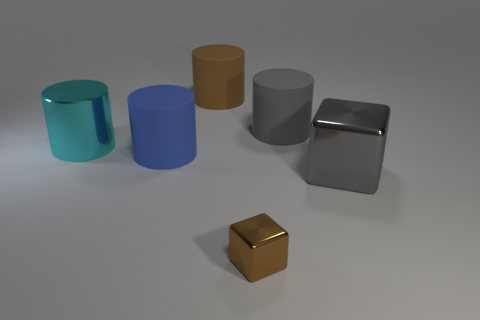Add 3 red metal things. How many objects exist? 9 Subtract all cubes. How many objects are left? 4 Add 3 tiny brown blocks. How many tiny brown blocks exist? 4 Subtract 0 green spheres. How many objects are left? 6 Subtract all small gray matte cubes. Subtract all large blue things. How many objects are left? 5 Add 1 small metal things. How many small metal things are left? 2 